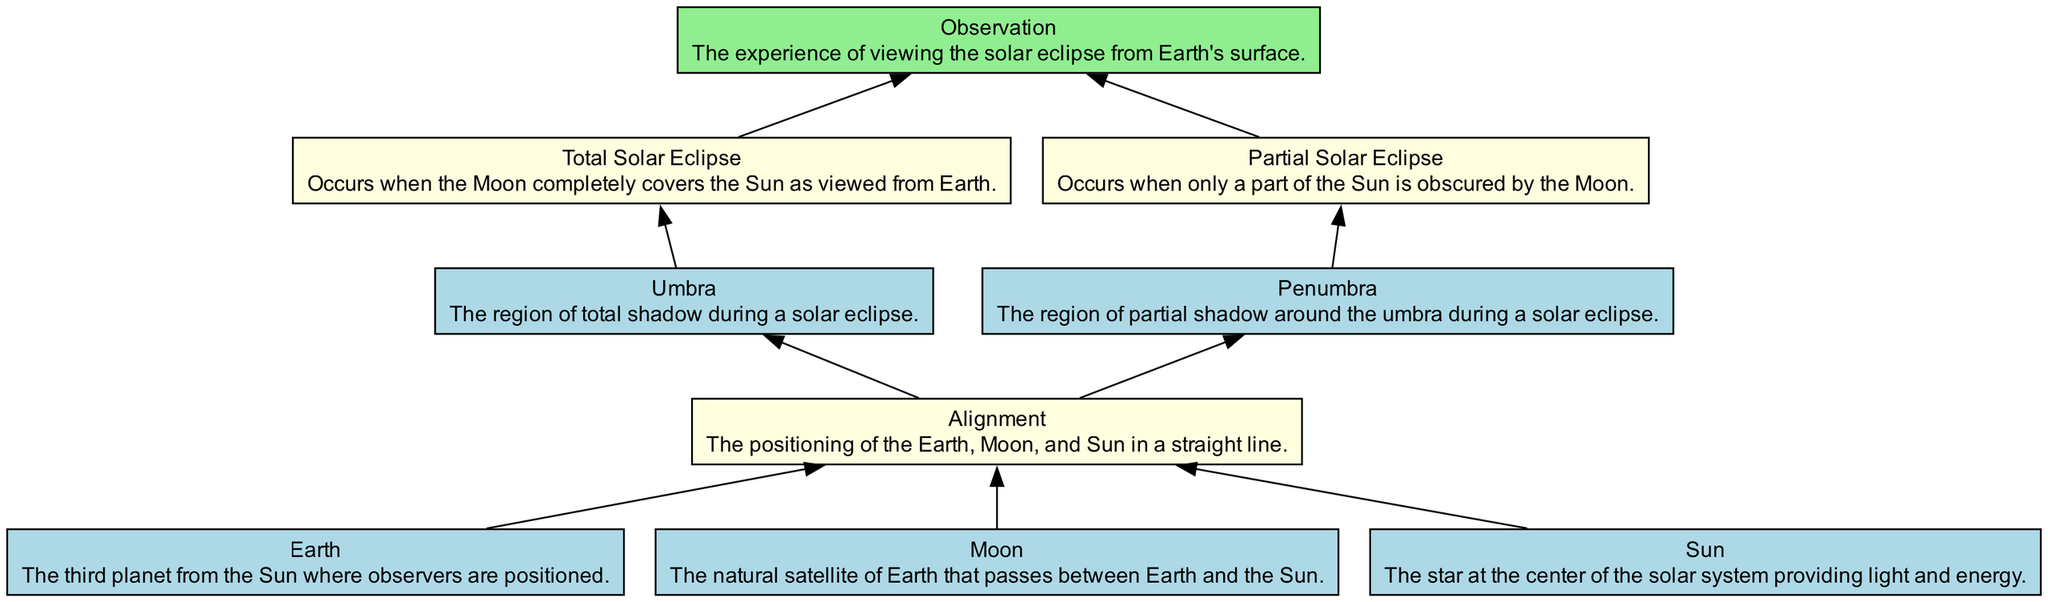What is the role of the Moon in the solar eclipse? The Moon passes between the Earth and the Sun, creating the conditions necessary for a solar eclipse to occur.
Answer: natural satellite of Earth How many types of solar eclipses are depicted in the diagram? The diagram shows two types of solar eclipses: total and partial.
Answer: two What follows the alignment of the Earth, Moon, and Sun? After the alignment event occurs, the umbra and penumbra regions develop, leading to the types of solar eclipses.
Answer: Umbra and Penumbra What is the observational effect of a total solar eclipse? During a total solar eclipse, observers will see a complete covering of the Sun by the Moon.
Answer: complete covering of the Sun Which region indicates partial shadow during a solar eclipse? The partial shadow around the umbra is referred to as the penumbra.
Answer: Penumbra What event occurs after the umbra is established? Following the establishment of the umbra, a total solar eclipse occurs, which is dependent on the complete coverage of the Sun.
Answer: Total Solar Eclipse Explain the relationship between Penumbra and Partial Solar Eclipse. The penumbra region is where observers will experience a partial solar eclipse when the Moon only partially covers the Sun.
Answer: Partial Solar Eclipse What provides light and energy at the center of the solar system? The Sun is the entity that provides light and energy, crucial for solar eclipses and life on Earth.
Answer: Sun What is necessary for the alignment event to occur? The positioning of Earth, Moon, and Sun in a straight line is necessary for the alignment event leading to a solar eclipse.
Answer: straight line alignment 